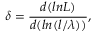Convert formula to latex. <formula><loc_0><loc_0><loc_500><loc_500>\delta = \frac { d ( \ln L ) } { d ( \ln ( l / \lambda ) ) } ,</formula> 